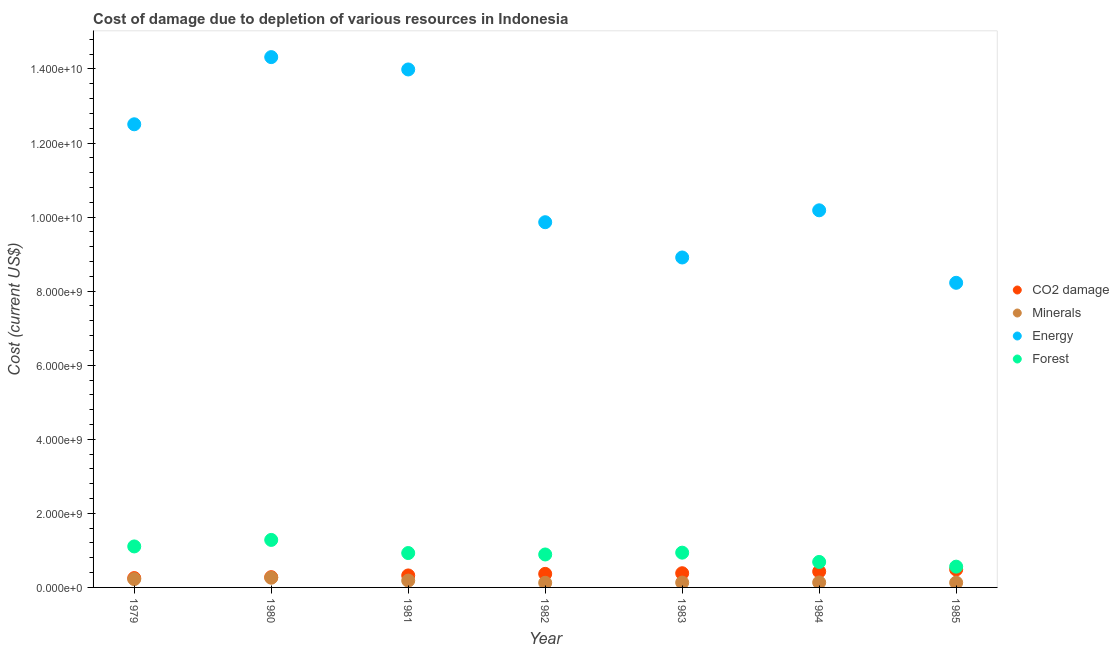How many different coloured dotlines are there?
Keep it short and to the point. 4. Is the number of dotlines equal to the number of legend labels?
Offer a terse response. Yes. What is the cost of damage due to depletion of minerals in 1984?
Provide a short and direct response. 1.34e+08. Across all years, what is the maximum cost of damage due to depletion of coal?
Your response must be concise. 4.84e+08. Across all years, what is the minimum cost of damage due to depletion of energy?
Keep it short and to the point. 8.23e+09. In which year was the cost of damage due to depletion of coal minimum?
Provide a short and direct response. 1979. What is the total cost of damage due to depletion of minerals in the graph?
Give a very brief answer. 1.19e+09. What is the difference between the cost of damage due to depletion of coal in 1979 and that in 1980?
Offer a very short reply. -2.50e+07. What is the difference between the cost of damage due to depletion of coal in 1983 and the cost of damage due to depletion of forests in 1980?
Provide a short and direct response. -9.00e+08. What is the average cost of damage due to depletion of energy per year?
Your answer should be very brief. 1.11e+1. In the year 1984, what is the difference between the cost of damage due to depletion of forests and cost of damage due to depletion of energy?
Ensure brevity in your answer.  -9.50e+09. What is the ratio of the cost of damage due to depletion of energy in 1980 to that in 1983?
Your answer should be compact. 1.61. Is the cost of damage due to depletion of coal in 1983 less than that in 1984?
Offer a very short reply. Yes. What is the difference between the highest and the second highest cost of damage due to depletion of coal?
Your response must be concise. 5.51e+07. What is the difference between the highest and the lowest cost of damage due to depletion of minerals?
Provide a short and direct response. 1.37e+08. Is it the case that in every year, the sum of the cost of damage due to depletion of energy and cost of damage due to depletion of minerals is greater than the sum of cost of damage due to depletion of coal and cost of damage due to depletion of forests?
Give a very brief answer. Yes. Is it the case that in every year, the sum of the cost of damage due to depletion of coal and cost of damage due to depletion of minerals is greater than the cost of damage due to depletion of energy?
Your answer should be very brief. No. Does the cost of damage due to depletion of minerals monotonically increase over the years?
Make the answer very short. No. Is the cost of damage due to depletion of energy strictly greater than the cost of damage due to depletion of forests over the years?
Ensure brevity in your answer.  Yes. Is the cost of damage due to depletion of energy strictly less than the cost of damage due to depletion of coal over the years?
Make the answer very short. No. Are the values on the major ticks of Y-axis written in scientific E-notation?
Your answer should be compact. Yes. Does the graph contain any zero values?
Your answer should be very brief. No. Where does the legend appear in the graph?
Your answer should be very brief. Center right. How are the legend labels stacked?
Ensure brevity in your answer.  Vertical. What is the title of the graph?
Make the answer very short. Cost of damage due to depletion of various resources in Indonesia . Does "Rule based governance" appear as one of the legend labels in the graph?
Keep it short and to the point. No. What is the label or title of the X-axis?
Keep it short and to the point. Year. What is the label or title of the Y-axis?
Ensure brevity in your answer.  Cost (current US$). What is the Cost (current US$) of CO2 damage in 1979?
Your response must be concise. 2.52e+08. What is the Cost (current US$) in Minerals in 1979?
Provide a succinct answer. 2.25e+08. What is the Cost (current US$) in Energy in 1979?
Provide a short and direct response. 1.25e+1. What is the Cost (current US$) of Forest in 1979?
Provide a short and direct response. 1.11e+09. What is the Cost (current US$) of CO2 damage in 1980?
Your answer should be very brief. 2.77e+08. What is the Cost (current US$) of Minerals in 1980?
Make the answer very short. 2.62e+08. What is the Cost (current US$) in Energy in 1980?
Keep it short and to the point. 1.43e+1. What is the Cost (current US$) of Forest in 1980?
Offer a terse response. 1.28e+09. What is the Cost (current US$) in CO2 damage in 1981?
Keep it short and to the point. 3.24e+08. What is the Cost (current US$) in Minerals in 1981?
Offer a very short reply. 1.85e+08. What is the Cost (current US$) of Energy in 1981?
Provide a short and direct response. 1.40e+1. What is the Cost (current US$) of Forest in 1981?
Keep it short and to the point. 9.29e+08. What is the Cost (current US$) in CO2 damage in 1982?
Your response must be concise. 3.66e+08. What is the Cost (current US$) of Minerals in 1982?
Ensure brevity in your answer.  1.25e+08. What is the Cost (current US$) in Energy in 1982?
Offer a terse response. 9.86e+09. What is the Cost (current US$) in Forest in 1982?
Offer a very short reply. 8.90e+08. What is the Cost (current US$) of CO2 damage in 1983?
Your answer should be compact. 3.83e+08. What is the Cost (current US$) of Minerals in 1983?
Ensure brevity in your answer.  1.31e+08. What is the Cost (current US$) of Energy in 1983?
Offer a terse response. 8.91e+09. What is the Cost (current US$) of Forest in 1983?
Ensure brevity in your answer.  9.39e+08. What is the Cost (current US$) of CO2 damage in 1984?
Give a very brief answer. 4.29e+08. What is the Cost (current US$) in Minerals in 1984?
Offer a very short reply. 1.34e+08. What is the Cost (current US$) in Energy in 1984?
Provide a short and direct response. 1.02e+1. What is the Cost (current US$) of Forest in 1984?
Your answer should be very brief. 6.88e+08. What is the Cost (current US$) in CO2 damage in 1985?
Offer a very short reply. 4.84e+08. What is the Cost (current US$) in Minerals in 1985?
Offer a very short reply. 1.29e+08. What is the Cost (current US$) in Energy in 1985?
Your answer should be compact. 8.23e+09. What is the Cost (current US$) in Forest in 1985?
Make the answer very short. 5.61e+08. Across all years, what is the maximum Cost (current US$) of CO2 damage?
Give a very brief answer. 4.84e+08. Across all years, what is the maximum Cost (current US$) in Minerals?
Ensure brevity in your answer.  2.62e+08. Across all years, what is the maximum Cost (current US$) of Energy?
Make the answer very short. 1.43e+1. Across all years, what is the maximum Cost (current US$) of Forest?
Offer a terse response. 1.28e+09. Across all years, what is the minimum Cost (current US$) of CO2 damage?
Provide a succinct answer. 2.52e+08. Across all years, what is the minimum Cost (current US$) in Minerals?
Your answer should be compact. 1.25e+08. Across all years, what is the minimum Cost (current US$) of Energy?
Offer a very short reply. 8.23e+09. Across all years, what is the minimum Cost (current US$) in Forest?
Give a very brief answer. 5.61e+08. What is the total Cost (current US$) in CO2 damage in the graph?
Keep it short and to the point. 2.52e+09. What is the total Cost (current US$) in Minerals in the graph?
Your answer should be very brief. 1.19e+09. What is the total Cost (current US$) in Energy in the graph?
Your answer should be compact. 7.80e+1. What is the total Cost (current US$) in Forest in the graph?
Your answer should be compact. 6.40e+09. What is the difference between the Cost (current US$) of CO2 damage in 1979 and that in 1980?
Give a very brief answer. -2.50e+07. What is the difference between the Cost (current US$) of Minerals in 1979 and that in 1980?
Your answer should be compact. -3.74e+07. What is the difference between the Cost (current US$) of Energy in 1979 and that in 1980?
Your answer should be compact. -1.81e+09. What is the difference between the Cost (current US$) in Forest in 1979 and that in 1980?
Provide a succinct answer. -1.76e+08. What is the difference between the Cost (current US$) in CO2 damage in 1979 and that in 1981?
Keep it short and to the point. -7.18e+07. What is the difference between the Cost (current US$) of Minerals in 1979 and that in 1981?
Your response must be concise. 4.05e+07. What is the difference between the Cost (current US$) of Energy in 1979 and that in 1981?
Make the answer very short. -1.48e+09. What is the difference between the Cost (current US$) of Forest in 1979 and that in 1981?
Keep it short and to the point. 1.78e+08. What is the difference between the Cost (current US$) in CO2 damage in 1979 and that in 1982?
Give a very brief answer. -1.14e+08. What is the difference between the Cost (current US$) of Minerals in 1979 and that in 1982?
Make the answer very short. 1.00e+08. What is the difference between the Cost (current US$) in Energy in 1979 and that in 1982?
Offer a terse response. 2.64e+09. What is the difference between the Cost (current US$) of Forest in 1979 and that in 1982?
Provide a succinct answer. 2.17e+08. What is the difference between the Cost (current US$) in CO2 damage in 1979 and that in 1983?
Your answer should be compact. -1.31e+08. What is the difference between the Cost (current US$) of Minerals in 1979 and that in 1983?
Provide a short and direct response. 9.44e+07. What is the difference between the Cost (current US$) of Energy in 1979 and that in 1983?
Your answer should be compact. 3.60e+09. What is the difference between the Cost (current US$) of Forest in 1979 and that in 1983?
Ensure brevity in your answer.  1.68e+08. What is the difference between the Cost (current US$) of CO2 damage in 1979 and that in 1984?
Provide a succinct answer. -1.77e+08. What is the difference between the Cost (current US$) of Minerals in 1979 and that in 1984?
Offer a terse response. 9.06e+07. What is the difference between the Cost (current US$) in Energy in 1979 and that in 1984?
Keep it short and to the point. 2.32e+09. What is the difference between the Cost (current US$) in Forest in 1979 and that in 1984?
Offer a terse response. 4.19e+08. What is the difference between the Cost (current US$) of CO2 damage in 1979 and that in 1985?
Provide a succinct answer. -2.33e+08. What is the difference between the Cost (current US$) of Minerals in 1979 and that in 1985?
Make the answer very short. 9.65e+07. What is the difference between the Cost (current US$) in Energy in 1979 and that in 1985?
Offer a terse response. 4.28e+09. What is the difference between the Cost (current US$) in Forest in 1979 and that in 1985?
Offer a terse response. 5.46e+08. What is the difference between the Cost (current US$) of CO2 damage in 1980 and that in 1981?
Your answer should be compact. -4.68e+07. What is the difference between the Cost (current US$) of Minerals in 1980 and that in 1981?
Ensure brevity in your answer.  7.79e+07. What is the difference between the Cost (current US$) in Energy in 1980 and that in 1981?
Give a very brief answer. 3.34e+08. What is the difference between the Cost (current US$) of Forest in 1980 and that in 1981?
Your answer should be compact. 3.54e+08. What is the difference between the Cost (current US$) of CO2 damage in 1980 and that in 1982?
Keep it short and to the point. -8.91e+07. What is the difference between the Cost (current US$) in Minerals in 1980 and that in 1982?
Offer a terse response. 1.37e+08. What is the difference between the Cost (current US$) in Energy in 1980 and that in 1982?
Provide a short and direct response. 4.46e+09. What is the difference between the Cost (current US$) in Forest in 1980 and that in 1982?
Your answer should be compact. 3.93e+08. What is the difference between the Cost (current US$) in CO2 damage in 1980 and that in 1983?
Your answer should be compact. -1.06e+08. What is the difference between the Cost (current US$) of Minerals in 1980 and that in 1983?
Keep it short and to the point. 1.32e+08. What is the difference between the Cost (current US$) in Energy in 1980 and that in 1983?
Give a very brief answer. 5.41e+09. What is the difference between the Cost (current US$) of Forest in 1980 and that in 1983?
Provide a short and direct response. 3.44e+08. What is the difference between the Cost (current US$) of CO2 damage in 1980 and that in 1984?
Offer a terse response. -1.52e+08. What is the difference between the Cost (current US$) of Minerals in 1980 and that in 1984?
Offer a terse response. 1.28e+08. What is the difference between the Cost (current US$) of Energy in 1980 and that in 1984?
Give a very brief answer. 4.14e+09. What is the difference between the Cost (current US$) in Forest in 1980 and that in 1984?
Ensure brevity in your answer.  5.95e+08. What is the difference between the Cost (current US$) of CO2 damage in 1980 and that in 1985?
Provide a succinct answer. -2.07e+08. What is the difference between the Cost (current US$) of Minerals in 1980 and that in 1985?
Provide a succinct answer. 1.34e+08. What is the difference between the Cost (current US$) of Energy in 1980 and that in 1985?
Your answer should be very brief. 6.09e+09. What is the difference between the Cost (current US$) of Forest in 1980 and that in 1985?
Offer a very short reply. 7.22e+08. What is the difference between the Cost (current US$) in CO2 damage in 1981 and that in 1982?
Provide a short and direct response. -4.23e+07. What is the difference between the Cost (current US$) of Minerals in 1981 and that in 1982?
Your response must be concise. 5.96e+07. What is the difference between the Cost (current US$) in Energy in 1981 and that in 1982?
Your answer should be very brief. 4.12e+09. What is the difference between the Cost (current US$) of Forest in 1981 and that in 1982?
Your answer should be compact. 3.88e+07. What is the difference between the Cost (current US$) of CO2 damage in 1981 and that in 1983?
Offer a very short reply. -5.96e+07. What is the difference between the Cost (current US$) of Minerals in 1981 and that in 1983?
Your answer should be very brief. 5.39e+07. What is the difference between the Cost (current US$) of Energy in 1981 and that in 1983?
Give a very brief answer. 5.08e+09. What is the difference between the Cost (current US$) in Forest in 1981 and that in 1983?
Make the answer very short. -1.02e+07. What is the difference between the Cost (current US$) of CO2 damage in 1981 and that in 1984?
Your answer should be compact. -1.06e+08. What is the difference between the Cost (current US$) in Minerals in 1981 and that in 1984?
Provide a short and direct response. 5.01e+07. What is the difference between the Cost (current US$) in Energy in 1981 and that in 1984?
Provide a short and direct response. 3.80e+09. What is the difference between the Cost (current US$) in Forest in 1981 and that in 1984?
Your answer should be very brief. 2.40e+08. What is the difference between the Cost (current US$) of CO2 damage in 1981 and that in 1985?
Keep it short and to the point. -1.61e+08. What is the difference between the Cost (current US$) of Minerals in 1981 and that in 1985?
Make the answer very short. 5.59e+07. What is the difference between the Cost (current US$) of Energy in 1981 and that in 1985?
Keep it short and to the point. 5.76e+09. What is the difference between the Cost (current US$) in Forest in 1981 and that in 1985?
Offer a terse response. 3.68e+08. What is the difference between the Cost (current US$) in CO2 damage in 1982 and that in 1983?
Offer a terse response. -1.73e+07. What is the difference between the Cost (current US$) of Minerals in 1982 and that in 1983?
Your response must be concise. -5.73e+06. What is the difference between the Cost (current US$) in Energy in 1982 and that in 1983?
Provide a short and direct response. 9.53e+08. What is the difference between the Cost (current US$) of Forest in 1982 and that in 1983?
Offer a terse response. -4.90e+07. What is the difference between the Cost (current US$) in CO2 damage in 1982 and that in 1984?
Your answer should be very brief. -6.32e+07. What is the difference between the Cost (current US$) in Minerals in 1982 and that in 1984?
Your response must be concise. -9.49e+06. What is the difference between the Cost (current US$) in Energy in 1982 and that in 1984?
Keep it short and to the point. -3.21e+08. What is the difference between the Cost (current US$) in Forest in 1982 and that in 1984?
Keep it short and to the point. 2.01e+08. What is the difference between the Cost (current US$) in CO2 damage in 1982 and that in 1985?
Offer a terse response. -1.18e+08. What is the difference between the Cost (current US$) of Minerals in 1982 and that in 1985?
Your answer should be compact. -3.65e+06. What is the difference between the Cost (current US$) of Energy in 1982 and that in 1985?
Offer a very short reply. 1.64e+09. What is the difference between the Cost (current US$) of Forest in 1982 and that in 1985?
Your answer should be very brief. 3.29e+08. What is the difference between the Cost (current US$) in CO2 damage in 1983 and that in 1984?
Your answer should be very brief. -4.59e+07. What is the difference between the Cost (current US$) of Minerals in 1983 and that in 1984?
Make the answer very short. -3.76e+06. What is the difference between the Cost (current US$) in Energy in 1983 and that in 1984?
Your response must be concise. -1.27e+09. What is the difference between the Cost (current US$) in Forest in 1983 and that in 1984?
Ensure brevity in your answer.  2.51e+08. What is the difference between the Cost (current US$) in CO2 damage in 1983 and that in 1985?
Your response must be concise. -1.01e+08. What is the difference between the Cost (current US$) in Minerals in 1983 and that in 1985?
Your response must be concise. 2.08e+06. What is the difference between the Cost (current US$) of Energy in 1983 and that in 1985?
Ensure brevity in your answer.  6.84e+08. What is the difference between the Cost (current US$) of Forest in 1983 and that in 1985?
Your answer should be very brief. 3.78e+08. What is the difference between the Cost (current US$) in CO2 damage in 1984 and that in 1985?
Give a very brief answer. -5.51e+07. What is the difference between the Cost (current US$) in Minerals in 1984 and that in 1985?
Give a very brief answer. 5.84e+06. What is the difference between the Cost (current US$) of Energy in 1984 and that in 1985?
Keep it short and to the point. 1.96e+09. What is the difference between the Cost (current US$) of Forest in 1984 and that in 1985?
Make the answer very short. 1.27e+08. What is the difference between the Cost (current US$) of CO2 damage in 1979 and the Cost (current US$) of Minerals in 1980?
Your answer should be compact. -1.05e+07. What is the difference between the Cost (current US$) of CO2 damage in 1979 and the Cost (current US$) of Energy in 1980?
Keep it short and to the point. -1.41e+1. What is the difference between the Cost (current US$) in CO2 damage in 1979 and the Cost (current US$) in Forest in 1980?
Keep it short and to the point. -1.03e+09. What is the difference between the Cost (current US$) in Minerals in 1979 and the Cost (current US$) in Energy in 1980?
Keep it short and to the point. -1.41e+1. What is the difference between the Cost (current US$) of Minerals in 1979 and the Cost (current US$) of Forest in 1980?
Keep it short and to the point. -1.06e+09. What is the difference between the Cost (current US$) of Energy in 1979 and the Cost (current US$) of Forest in 1980?
Your answer should be very brief. 1.12e+1. What is the difference between the Cost (current US$) in CO2 damage in 1979 and the Cost (current US$) in Minerals in 1981?
Keep it short and to the point. 6.74e+07. What is the difference between the Cost (current US$) in CO2 damage in 1979 and the Cost (current US$) in Energy in 1981?
Your response must be concise. -1.37e+1. What is the difference between the Cost (current US$) in CO2 damage in 1979 and the Cost (current US$) in Forest in 1981?
Offer a terse response. -6.77e+08. What is the difference between the Cost (current US$) of Minerals in 1979 and the Cost (current US$) of Energy in 1981?
Offer a terse response. -1.38e+1. What is the difference between the Cost (current US$) of Minerals in 1979 and the Cost (current US$) of Forest in 1981?
Your answer should be very brief. -7.03e+08. What is the difference between the Cost (current US$) in Energy in 1979 and the Cost (current US$) in Forest in 1981?
Ensure brevity in your answer.  1.16e+1. What is the difference between the Cost (current US$) of CO2 damage in 1979 and the Cost (current US$) of Minerals in 1982?
Your response must be concise. 1.27e+08. What is the difference between the Cost (current US$) in CO2 damage in 1979 and the Cost (current US$) in Energy in 1982?
Offer a very short reply. -9.61e+09. What is the difference between the Cost (current US$) in CO2 damage in 1979 and the Cost (current US$) in Forest in 1982?
Provide a succinct answer. -6.38e+08. What is the difference between the Cost (current US$) in Minerals in 1979 and the Cost (current US$) in Energy in 1982?
Provide a short and direct response. -9.64e+09. What is the difference between the Cost (current US$) of Minerals in 1979 and the Cost (current US$) of Forest in 1982?
Offer a terse response. -6.65e+08. What is the difference between the Cost (current US$) of Energy in 1979 and the Cost (current US$) of Forest in 1982?
Your answer should be very brief. 1.16e+1. What is the difference between the Cost (current US$) in CO2 damage in 1979 and the Cost (current US$) in Minerals in 1983?
Provide a short and direct response. 1.21e+08. What is the difference between the Cost (current US$) in CO2 damage in 1979 and the Cost (current US$) in Energy in 1983?
Offer a terse response. -8.66e+09. What is the difference between the Cost (current US$) in CO2 damage in 1979 and the Cost (current US$) in Forest in 1983?
Provide a succinct answer. -6.87e+08. What is the difference between the Cost (current US$) in Minerals in 1979 and the Cost (current US$) in Energy in 1983?
Your answer should be very brief. -8.68e+09. What is the difference between the Cost (current US$) in Minerals in 1979 and the Cost (current US$) in Forest in 1983?
Your response must be concise. -7.14e+08. What is the difference between the Cost (current US$) of Energy in 1979 and the Cost (current US$) of Forest in 1983?
Offer a very short reply. 1.16e+1. What is the difference between the Cost (current US$) of CO2 damage in 1979 and the Cost (current US$) of Minerals in 1984?
Offer a very short reply. 1.17e+08. What is the difference between the Cost (current US$) in CO2 damage in 1979 and the Cost (current US$) in Energy in 1984?
Ensure brevity in your answer.  -9.93e+09. What is the difference between the Cost (current US$) of CO2 damage in 1979 and the Cost (current US$) of Forest in 1984?
Your response must be concise. -4.36e+08. What is the difference between the Cost (current US$) of Minerals in 1979 and the Cost (current US$) of Energy in 1984?
Your answer should be very brief. -9.96e+09. What is the difference between the Cost (current US$) in Minerals in 1979 and the Cost (current US$) in Forest in 1984?
Give a very brief answer. -4.63e+08. What is the difference between the Cost (current US$) in Energy in 1979 and the Cost (current US$) in Forest in 1984?
Give a very brief answer. 1.18e+1. What is the difference between the Cost (current US$) of CO2 damage in 1979 and the Cost (current US$) of Minerals in 1985?
Offer a very short reply. 1.23e+08. What is the difference between the Cost (current US$) of CO2 damage in 1979 and the Cost (current US$) of Energy in 1985?
Make the answer very short. -7.97e+09. What is the difference between the Cost (current US$) of CO2 damage in 1979 and the Cost (current US$) of Forest in 1985?
Offer a very short reply. -3.09e+08. What is the difference between the Cost (current US$) of Minerals in 1979 and the Cost (current US$) of Energy in 1985?
Your answer should be compact. -8.00e+09. What is the difference between the Cost (current US$) of Minerals in 1979 and the Cost (current US$) of Forest in 1985?
Offer a very short reply. -3.36e+08. What is the difference between the Cost (current US$) of Energy in 1979 and the Cost (current US$) of Forest in 1985?
Offer a terse response. 1.19e+1. What is the difference between the Cost (current US$) of CO2 damage in 1980 and the Cost (current US$) of Minerals in 1981?
Make the answer very short. 9.24e+07. What is the difference between the Cost (current US$) in CO2 damage in 1980 and the Cost (current US$) in Energy in 1981?
Provide a short and direct response. -1.37e+1. What is the difference between the Cost (current US$) of CO2 damage in 1980 and the Cost (current US$) of Forest in 1981?
Your response must be concise. -6.52e+08. What is the difference between the Cost (current US$) in Minerals in 1980 and the Cost (current US$) in Energy in 1981?
Your answer should be very brief. -1.37e+1. What is the difference between the Cost (current US$) of Minerals in 1980 and the Cost (current US$) of Forest in 1981?
Your answer should be very brief. -6.66e+08. What is the difference between the Cost (current US$) in Energy in 1980 and the Cost (current US$) in Forest in 1981?
Ensure brevity in your answer.  1.34e+1. What is the difference between the Cost (current US$) in CO2 damage in 1980 and the Cost (current US$) in Minerals in 1982?
Provide a short and direct response. 1.52e+08. What is the difference between the Cost (current US$) in CO2 damage in 1980 and the Cost (current US$) in Energy in 1982?
Give a very brief answer. -9.59e+09. What is the difference between the Cost (current US$) in CO2 damage in 1980 and the Cost (current US$) in Forest in 1982?
Make the answer very short. -6.13e+08. What is the difference between the Cost (current US$) of Minerals in 1980 and the Cost (current US$) of Energy in 1982?
Make the answer very short. -9.60e+09. What is the difference between the Cost (current US$) in Minerals in 1980 and the Cost (current US$) in Forest in 1982?
Keep it short and to the point. -6.27e+08. What is the difference between the Cost (current US$) in Energy in 1980 and the Cost (current US$) in Forest in 1982?
Provide a short and direct response. 1.34e+1. What is the difference between the Cost (current US$) of CO2 damage in 1980 and the Cost (current US$) of Minerals in 1983?
Make the answer very short. 1.46e+08. What is the difference between the Cost (current US$) in CO2 damage in 1980 and the Cost (current US$) in Energy in 1983?
Keep it short and to the point. -8.63e+09. What is the difference between the Cost (current US$) of CO2 damage in 1980 and the Cost (current US$) of Forest in 1983?
Your answer should be compact. -6.62e+08. What is the difference between the Cost (current US$) in Minerals in 1980 and the Cost (current US$) in Energy in 1983?
Your answer should be very brief. -8.65e+09. What is the difference between the Cost (current US$) of Minerals in 1980 and the Cost (current US$) of Forest in 1983?
Offer a very short reply. -6.76e+08. What is the difference between the Cost (current US$) in Energy in 1980 and the Cost (current US$) in Forest in 1983?
Provide a succinct answer. 1.34e+1. What is the difference between the Cost (current US$) of CO2 damage in 1980 and the Cost (current US$) of Minerals in 1984?
Your answer should be very brief. 1.42e+08. What is the difference between the Cost (current US$) of CO2 damage in 1980 and the Cost (current US$) of Energy in 1984?
Provide a succinct answer. -9.91e+09. What is the difference between the Cost (current US$) in CO2 damage in 1980 and the Cost (current US$) in Forest in 1984?
Provide a succinct answer. -4.11e+08. What is the difference between the Cost (current US$) of Minerals in 1980 and the Cost (current US$) of Energy in 1984?
Offer a terse response. -9.92e+09. What is the difference between the Cost (current US$) in Minerals in 1980 and the Cost (current US$) in Forest in 1984?
Provide a short and direct response. -4.26e+08. What is the difference between the Cost (current US$) of Energy in 1980 and the Cost (current US$) of Forest in 1984?
Your answer should be compact. 1.36e+1. What is the difference between the Cost (current US$) in CO2 damage in 1980 and the Cost (current US$) in Minerals in 1985?
Offer a terse response. 1.48e+08. What is the difference between the Cost (current US$) of CO2 damage in 1980 and the Cost (current US$) of Energy in 1985?
Your response must be concise. -7.95e+09. What is the difference between the Cost (current US$) of CO2 damage in 1980 and the Cost (current US$) of Forest in 1985?
Your answer should be very brief. -2.84e+08. What is the difference between the Cost (current US$) of Minerals in 1980 and the Cost (current US$) of Energy in 1985?
Provide a short and direct response. -7.96e+09. What is the difference between the Cost (current US$) in Minerals in 1980 and the Cost (current US$) in Forest in 1985?
Provide a short and direct response. -2.99e+08. What is the difference between the Cost (current US$) of Energy in 1980 and the Cost (current US$) of Forest in 1985?
Your answer should be compact. 1.38e+1. What is the difference between the Cost (current US$) of CO2 damage in 1981 and the Cost (current US$) of Minerals in 1982?
Ensure brevity in your answer.  1.99e+08. What is the difference between the Cost (current US$) in CO2 damage in 1981 and the Cost (current US$) in Energy in 1982?
Make the answer very short. -9.54e+09. What is the difference between the Cost (current US$) in CO2 damage in 1981 and the Cost (current US$) in Forest in 1982?
Provide a succinct answer. -5.66e+08. What is the difference between the Cost (current US$) in Minerals in 1981 and the Cost (current US$) in Energy in 1982?
Give a very brief answer. -9.68e+09. What is the difference between the Cost (current US$) in Minerals in 1981 and the Cost (current US$) in Forest in 1982?
Your answer should be compact. -7.05e+08. What is the difference between the Cost (current US$) in Energy in 1981 and the Cost (current US$) in Forest in 1982?
Your answer should be compact. 1.31e+1. What is the difference between the Cost (current US$) of CO2 damage in 1981 and the Cost (current US$) of Minerals in 1983?
Offer a very short reply. 1.93e+08. What is the difference between the Cost (current US$) in CO2 damage in 1981 and the Cost (current US$) in Energy in 1983?
Provide a succinct answer. -8.59e+09. What is the difference between the Cost (current US$) of CO2 damage in 1981 and the Cost (current US$) of Forest in 1983?
Your answer should be very brief. -6.15e+08. What is the difference between the Cost (current US$) of Minerals in 1981 and the Cost (current US$) of Energy in 1983?
Give a very brief answer. -8.73e+09. What is the difference between the Cost (current US$) in Minerals in 1981 and the Cost (current US$) in Forest in 1983?
Your answer should be compact. -7.54e+08. What is the difference between the Cost (current US$) of Energy in 1981 and the Cost (current US$) of Forest in 1983?
Your answer should be very brief. 1.30e+1. What is the difference between the Cost (current US$) of CO2 damage in 1981 and the Cost (current US$) of Minerals in 1984?
Offer a very short reply. 1.89e+08. What is the difference between the Cost (current US$) of CO2 damage in 1981 and the Cost (current US$) of Energy in 1984?
Offer a terse response. -9.86e+09. What is the difference between the Cost (current US$) in CO2 damage in 1981 and the Cost (current US$) in Forest in 1984?
Offer a terse response. -3.65e+08. What is the difference between the Cost (current US$) of Minerals in 1981 and the Cost (current US$) of Energy in 1984?
Your answer should be very brief. -1.00e+1. What is the difference between the Cost (current US$) of Minerals in 1981 and the Cost (current US$) of Forest in 1984?
Your answer should be very brief. -5.04e+08. What is the difference between the Cost (current US$) in Energy in 1981 and the Cost (current US$) in Forest in 1984?
Provide a short and direct response. 1.33e+1. What is the difference between the Cost (current US$) in CO2 damage in 1981 and the Cost (current US$) in Minerals in 1985?
Your answer should be compact. 1.95e+08. What is the difference between the Cost (current US$) of CO2 damage in 1981 and the Cost (current US$) of Energy in 1985?
Offer a very short reply. -7.90e+09. What is the difference between the Cost (current US$) in CO2 damage in 1981 and the Cost (current US$) in Forest in 1985?
Keep it short and to the point. -2.37e+08. What is the difference between the Cost (current US$) in Minerals in 1981 and the Cost (current US$) in Energy in 1985?
Your response must be concise. -8.04e+09. What is the difference between the Cost (current US$) of Minerals in 1981 and the Cost (current US$) of Forest in 1985?
Your response must be concise. -3.76e+08. What is the difference between the Cost (current US$) of Energy in 1981 and the Cost (current US$) of Forest in 1985?
Your response must be concise. 1.34e+1. What is the difference between the Cost (current US$) of CO2 damage in 1982 and the Cost (current US$) of Minerals in 1983?
Make the answer very short. 2.35e+08. What is the difference between the Cost (current US$) in CO2 damage in 1982 and the Cost (current US$) in Energy in 1983?
Keep it short and to the point. -8.54e+09. What is the difference between the Cost (current US$) in CO2 damage in 1982 and the Cost (current US$) in Forest in 1983?
Keep it short and to the point. -5.73e+08. What is the difference between the Cost (current US$) in Minerals in 1982 and the Cost (current US$) in Energy in 1983?
Provide a short and direct response. -8.79e+09. What is the difference between the Cost (current US$) of Minerals in 1982 and the Cost (current US$) of Forest in 1983?
Keep it short and to the point. -8.14e+08. What is the difference between the Cost (current US$) in Energy in 1982 and the Cost (current US$) in Forest in 1983?
Give a very brief answer. 8.92e+09. What is the difference between the Cost (current US$) in CO2 damage in 1982 and the Cost (current US$) in Minerals in 1984?
Give a very brief answer. 2.32e+08. What is the difference between the Cost (current US$) of CO2 damage in 1982 and the Cost (current US$) of Energy in 1984?
Your answer should be very brief. -9.82e+09. What is the difference between the Cost (current US$) of CO2 damage in 1982 and the Cost (current US$) of Forest in 1984?
Give a very brief answer. -3.22e+08. What is the difference between the Cost (current US$) in Minerals in 1982 and the Cost (current US$) in Energy in 1984?
Your response must be concise. -1.01e+1. What is the difference between the Cost (current US$) of Minerals in 1982 and the Cost (current US$) of Forest in 1984?
Offer a terse response. -5.63e+08. What is the difference between the Cost (current US$) in Energy in 1982 and the Cost (current US$) in Forest in 1984?
Your answer should be very brief. 9.17e+09. What is the difference between the Cost (current US$) of CO2 damage in 1982 and the Cost (current US$) of Minerals in 1985?
Offer a very short reply. 2.37e+08. What is the difference between the Cost (current US$) in CO2 damage in 1982 and the Cost (current US$) in Energy in 1985?
Offer a terse response. -7.86e+09. What is the difference between the Cost (current US$) of CO2 damage in 1982 and the Cost (current US$) of Forest in 1985?
Your response must be concise. -1.95e+08. What is the difference between the Cost (current US$) of Minerals in 1982 and the Cost (current US$) of Energy in 1985?
Ensure brevity in your answer.  -8.10e+09. What is the difference between the Cost (current US$) of Minerals in 1982 and the Cost (current US$) of Forest in 1985?
Ensure brevity in your answer.  -4.36e+08. What is the difference between the Cost (current US$) in Energy in 1982 and the Cost (current US$) in Forest in 1985?
Ensure brevity in your answer.  9.30e+09. What is the difference between the Cost (current US$) in CO2 damage in 1983 and the Cost (current US$) in Minerals in 1984?
Make the answer very short. 2.49e+08. What is the difference between the Cost (current US$) of CO2 damage in 1983 and the Cost (current US$) of Energy in 1984?
Ensure brevity in your answer.  -9.80e+09. What is the difference between the Cost (current US$) of CO2 damage in 1983 and the Cost (current US$) of Forest in 1984?
Keep it short and to the point. -3.05e+08. What is the difference between the Cost (current US$) in Minerals in 1983 and the Cost (current US$) in Energy in 1984?
Keep it short and to the point. -1.01e+1. What is the difference between the Cost (current US$) in Minerals in 1983 and the Cost (current US$) in Forest in 1984?
Provide a succinct answer. -5.58e+08. What is the difference between the Cost (current US$) of Energy in 1983 and the Cost (current US$) of Forest in 1984?
Ensure brevity in your answer.  8.22e+09. What is the difference between the Cost (current US$) in CO2 damage in 1983 and the Cost (current US$) in Minerals in 1985?
Offer a terse response. 2.55e+08. What is the difference between the Cost (current US$) of CO2 damage in 1983 and the Cost (current US$) of Energy in 1985?
Ensure brevity in your answer.  -7.84e+09. What is the difference between the Cost (current US$) in CO2 damage in 1983 and the Cost (current US$) in Forest in 1985?
Give a very brief answer. -1.78e+08. What is the difference between the Cost (current US$) of Minerals in 1983 and the Cost (current US$) of Energy in 1985?
Offer a very short reply. -8.10e+09. What is the difference between the Cost (current US$) in Minerals in 1983 and the Cost (current US$) in Forest in 1985?
Make the answer very short. -4.30e+08. What is the difference between the Cost (current US$) in Energy in 1983 and the Cost (current US$) in Forest in 1985?
Your response must be concise. 8.35e+09. What is the difference between the Cost (current US$) of CO2 damage in 1984 and the Cost (current US$) of Minerals in 1985?
Offer a terse response. 3.01e+08. What is the difference between the Cost (current US$) of CO2 damage in 1984 and the Cost (current US$) of Energy in 1985?
Ensure brevity in your answer.  -7.80e+09. What is the difference between the Cost (current US$) of CO2 damage in 1984 and the Cost (current US$) of Forest in 1985?
Keep it short and to the point. -1.32e+08. What is the difference between the Cost (current US$) of Minerals in 1984 and the Cost (current US$) of Energy in 1985?
Your answer should be compact. -8.09e+09. What is the difference between the Cost (current US$) in Minerals in 1984 and the Cost (current US$) in Forest in 1985?
Offer a terse response. -4.26e+08. What is the difference between the Cost (current US$) of Energy in 1984 and the Cost (current US$) of Forest in 1985?
Give a very brief answer. 9.62e+09. What is the average Cost (current US$) of CO2 damage per year?
Offer a terse response. 3.59e+08. What is the average Cost (current US$) in Minerals per year?
Offer a terse response. 1.70e+08. What is the average Cost (current US$) in Energy per year?
Provide a short and direct response. 1.11e+1. What is the average Cost (current US$) of Forest per year?
Provide a succinct answer. 9.14e+08. In the year 1979, what is the difference between the Cost (current US$) of CO2 damage and Cost (current US$) of Minerals?
Your answer should be very brief. 2.68e+07. In the year 1979, what is the difference between the Cost (current US$) of CO2 damage and Cost (current US$) of Energy?
Provide a short and direct response. -1.23e+1. In the year 1979, what is the difference between the Cost (current US$) of CO2 damage and Cost (current US$) of Forest?
Your response must be concise. -8.55e+08. In the year 1979, what is the difference between the Cost (current US$) of Minerals and Cost (current US$) of Energy?
Give a very brief answer. -1.23e+1. In the year 1979, what is the difference between the Cost (current US$) of Minerals and Cost (current US$) of Forest?
Offer a terse response. -8.82e+08. In the year 1979, what is the difference between the Cost (current US$) in Energy and Cost (current US$) in Forest?
Ensure brevity in your answer.  1.14e+1. In the year 1980, what is the difference between the Cost (current US$) in CO2 damage and Cost (current US$) in Minerals?
Your answer should be compact. 1.45e+07. In the year 1980, what is the difference between the Cost (current US$) in CO2 damage and Cost (current US$) in Energy?
Make the answer very short. -1.40e+1. In the year 1980, what is the difference between the Cost (current US$) of CO2 damage and Cost (current US$) of Forest?
Your answer should be very brief. -1.01e+09. In the year 1980, what is the difference between the Cost (current US$) in Minerals and Cost (current US$) in Energy?
Ensure brevity in your answer.  -1.41e+1. In the year 1980, what is the difference between the Cost (current US$) in Minerals and Cost (current US$) in Forest?
Offer a terse response. -1.02e+09. In the year 1980, what is the difference between the Cost (current US$) in Energy and Cost (current US$) in Forest?
Provide a succinct answer. 1.30e+1. In the year 1981, what is the difference between the Cost (current US$) of CO2 damage and Cost (current US$) of Minerals?
Your response must be concise. 1.39e+08. In the year 1981, what is the difference between the Cost (current US$) of CO2 damage and Cost (current US$) of Energy?
Provide a succinct answer. -1.37e+1. In the year 1981, what is the difference between the Cost (current US$) of CO2 damage and Cost (current US$) of Forest?
Provide a succinct answer. -6.05e+08. In the year 1981, what is the difference between the Cost (current US$) in Minerals and Cost (current US$) in Energy?
Offer a very short reply. -1.38e+1. In the year 1981, what is the difference between the Cost (current US$) in Minerals and Cost (current US$) in Forest?
Provide a succinct answer. -7.44e+08. In the year 1981, what is the difference between the Cost (current US$) of Energy and Cost (current US$) of Forest?
Offer a terse response. 1.31e+1. In the year 1982, what is the difference between the Cost (current US$) in CO2 damage and Cost (current US$) in Minerals?
Your answer should be very brief. 2.41e+08. In the year 1982, what is the difference between the Cost (current US$) of CO2 damage and Cost (current US$) of Energy?
Keep it short and to the point. -9.50e+09. In the year 1982, what is the difference between the Cost (current US$) in CO2 damage and Cost (current US$) in Forest?
Give a very brief answer. -5.24e+08. In the year 1982, what is the difference between the Cost (current US$) in Minerals and Cost (current US$) in Energy?
Ensure brevity in your answer.  -9.74e+09. In the year 1982, what is the difference between the Cost (current US$) in Minerals and Cost (current US$) in Forest?
Make the answer very short. -7.65e+08. In the year 1982, what is the difference between the Cost (current US$) of Energy and Cost (current US$) of Forest?
Give a very brief answer. 8.97e+09. In the year 1983, what is the difference between the Cost (current US$) in CO2 damage and Cost (current US$) in Minerals?
Provide a short and direct response. 2.53e+08. In the year 1983, what is the difference between the Cost (current US$) of CO2 damage and Cost (current US$) of Energy?
Provide a succinct answer. -8.53e+09. In the year 1983, what is the difference between the Cost (current US$) in CO2 damage and Cost (current US$) in Forest?
Provide a succinct answer. -5.55e+08. In the year 1983, what is the difference between the Cost (current US$) in Minerals and Cost (current US$) in Energy?
Your response must be concise. -8.78e+09. In the year 1983, what is the difference between the Cost (current US$) of Minerals and Cost (current US$) of Forest?
Your answer should be very brief. -8.08e+08. In the year 1983, what is the difference between the Cost (current US$) of Energy and Cost (current US$) of Forest?
Your response must be concise. 7.97e+09. In the year 1984, what is the difference between the Cost (current US$) of CO2 damage and Cost (current US$) of Minerals?
Provide a succinct answer. 2.95e+08. In the year 1984, what is the difference between the Cost (current US$) of CO2 damage and Cost (current US$) of Energy?
Keep it short and to the point. -9.75e+09. In the year 1984, what is the difference between the Cost (current US$) of CO2 damage and Cost (current US$) of Forest?
Make the answer very short. -2.59e+08. In the year 1984, what is the difference between the Cost (current US$) in Minerals and Cost (current US$) in Energy?
Your answer should be compact. -1.00e+1. In the year 1984, what is the difference between the Cost (current US$) in Minerals and Cost (current US$) in Forest?
Your response must be concise. -5.54e+08. In the year 1984, what is the difference between the Cost (current US$) in Energy and Cost (current US$) in Forest?
Your answer should be very brief. 9.50e+09. In the year 1985, what is the difference between the Cost (current US$) in CO2 damage and Cost (current US$) in Minerals?
Your answer should be very brief. 3.56e+08. In the year 1985, what is the difference between the Cost (current US$) of CO2 damage and Cost (current US$) of Energy?
Keep it short and to the point. -7.74e+09. In the year 1985, what is the difference between the Cost (current US$) in CO2 damage and Cost (current US$) in Forest?
Give a very brief answer. -7.65e+07. In the year 1985, what is the difference between the Cost (current US$) in Minerals and Cost (current US$) in Energy?
Keep it short and to the point. -8.10e+09. In the year 1985, what is the difference between the Cost (current US$) of Minerals and Cost (current US$) of Forest?
Provide a succinct answer. -4.32e+08. In the year 1985, what is the difference between the Cost (current US$) of Energy and Cost (current US$) of Forest?
Offer a very short reply. 7.67e+09. What is the ratio of the Cost (current US$) in CO2 damage in 1979 to that in 1980?
Offer a very short reply. 0.91. What is the ratio of the Cost (current US$) in Minerals in 1979 to that in 1980?
Your answer should be very brief. 0.86. What is the ratio of the Cost (current US$) in Energy in 1979 to that in 1980?
Your answer should be very brief. 0.87. What is the ratio of the Cost (current US$) in Forest in 1979 to that in 1980?
Provide a short and direct response. 0.86. What is the ratio of the Cost (current US$) in CO2 damage in 1979 to that in 1981?
Keep it short and to the point. 0.78. What is the ratio of the Cost (current US$) of Minerals in 1979 to that in 1981?
Make the answer very short. 1.22. What is the ratio of the Cost (current US$) of Energy in 1979 to that in 1981?
Make the answer very short. 0.89. What is the ratio of the Cost (current US$) of Forest in 1979 to that in 1981?
Make the answer very short. 1.19. What is the ratio of the Cost (current US$) in CO2 damage in 1979 to that in 1982?
Offer a terse response. 0.69. What is the ratio of the Cost (current US$) in Minerals in 1979 to that in 1982?
Your response must be concise. 1.8. What is the ratio of the Cost (current US$) of Energy in 1979 to that in 1982?
Ensure brevity in your answer.  1.27. What is the ratio of the Cost (current US$) of Forest in 1979 to that in 1982?
Your answer should be compact. 1.24. What is the ratio of the Cost (current US$) of CO2 damage in 1979 to that in 1983?
Your response must be concise. 0.66. What is the ratio of the Cost (current US$) in Minerals in 1979 to that in 1983?
Give a very brief answer. 1.72. What is the ratio of the Cost (current US$) in Energy in 1979 to that in 1983?
Your response must be concise. 1.4. What is the ratio of the Cost (current US$) in Forest in 1979 to that in 1983?
Ensure brevity in your answer.  1.18. What is the ratio of the Cost (current US$) in CO2 damage in 1979 to that in 1984?
Keep it short and to the point. 0.59. What is the ratio of the Cost (current US$) in Minerals in 1979 to that in 1984?
Make the answer very short. 1.67. What is the ratio of the Cost (current US$) of Energy in 1979 to that in 1984?
Offer a very short reply. 1.23. What is the ratio of the Cost (current US$) in Forest in 1979 to that in 1984?
Provide a succinct answer. 1.61. What is the ratio of the Cost (current US$) of CO2 damage in 1979 to that in 1985?
Provide a succinct answer. 0.52. What is the ratio of the Cost (current US$) of Minerals in 1979 to that in 1985?
Keep it short and to the point. 1.75. What is the ratio of the Cost (current US$) in Energy in 1979 to that in 1985?
Provide a succinct answer. 1.52. What is the ratio of the Cost (current US$) in Forest in 1979 to that in 1985?
Give a very brief answer. 1.97. What is the ratio of the Cost (current US$) of CO2 damage in 1980 to that in 1981?
Give a very brief answer. 0.86. What is the ratio of the Cost (current US$) in Minerals in 1980 to that in 1981?
Make the answer very short. 1.42. What is the ratio of the Cost (current US$) in Energy in 1980 to that in 1981?
Make the answer very short. 1.02. What is the ratio of the Cost (current US$) in Forest in 1980 to that in 1981?
Your answer should be very brief. 1.38. What is the ratio of the Cost (current US$) in CO2 damage in 1980 to that in 1982?
Your answer should be very brief. 0.76. What is the ratio of the Cost (current US$) in Minerals in 1980 to that in 1982?
Your response must be concise. 2.1. What is the ratio of the Cost (current US$) in Energy in 1980 to that in 1982?
Provide a short and direct response. 1.45. What is the ratio of the Cost (current US$) of Forest in 1980 to that in 1982?
Provide a short and direct response. 1.44. What is the ratio of the Cost (current US$) in CO2 damage in 1980 to that in 1983?
Offer a very short reply. 0.72. What is the ratio of the Cost (current US$) of Minerals in 1980 to that in 1983?
Provide a short and direct response. 2.01. What is the ratio of the Cost (current US$) in Energy in 1980 to that in 1983?
Provide a succinct answer. 1.61. What is the ratio of the Cost (current US$) of Forest in 1980 to that in 1983?
Provide a short and direct response. 1.37. What is the ratio of the Cost (current US$) of CO2 damage in 1980 to that in 1984?
Provide a short and direct response. 0.65. What is the ratio of the Cost (current US$) of Minerals in 1980 to that in 1984?
Keep it short and to the point. 1.95. What is the ratio of the Cost (current US$) of Energy in 1980 to that in 1984?
Your answer should be very brief. 1.41. What is the ratio of the Cost (current US$) of Forest in 1980 to that in 1984?
Ensure brevity in your answer.  1.86. What is the ratio of the Cost (current US$) of CO2 damage in 1980 to that in 1985?
Provide a succinct answer. 0.57. What is the ratio of the Cost (current US$) in Minerals in 1980 to that in 1985?
Ensure brevity in your answer.  2.04. What is the ratio of the Cost (current US$) of Energy in 1980 to that in 1985?
Provide a short and direct response. 1.74. What is the ratio of the Cost (current US$) in Forest in 1980 to that in 1985?
Ensure brevity in your answer.  2.29. What is the ratio of the Cost (current US$) of CO2 damage in 1981 to that in 1982?
Make the answer very short. 0.88. What is the ratio of the Cost (current US$) of Minerals in 1981 to that in 1982?
Your answer should be compact. 1.48. What is the ratio of the Cost (current US$) in Energy in 1981 to that in 1982?
Provide a short and direct response. 1.42. What is the ratio of the Cost (current US$) of Forest in 1981 to that in 1982?
Provide a short and direct response. 1.04. What is the ratio of the Cost (current US$) in CO2 damage in 1981 to that in 1983?
Your answer should be very brief. 0.84. What is the ratio of the Cost (current US$) in Minerals in 1981 to that in 1983?
Provide a short and direct response. 1.41. What is the ratio of the Cost (current US$) of Energy in 1981 to that in 1983?
Give a very brief answer. 1.57. What is the ratio of the Cost (current US$) in Forest in 1981 to that in 1983?
Provide a succinct answer. 0.99. What is the ratio of the Cost (current US$) in CO2 damage in 1981 to that in 1984?
Ensure brevity in your answer.  0.75. What is the ratio of the Cost (current US$) of Minerals in 1981 to that in 1984?
Offer a very short reply. 1.37. What is the ratio of the Cost (current US$) in Energy in 1981 to that in 1984?
Your answer should be compact. 1.37. What is the ratio of the Cost (current US$) in Forest in 1981 to that in 1984?
Ensure brevity in your answer.  1.35. What is the ratio of the Cost (current US$) of CO2 damage in 1981 to that in 1985?
Provide a succinct answer. 0.67. What is the ratio of the Cost (current US$) in Minerals in 1981 to that in 1985?
Ensure brevity in your answer.  1.43. What is the ratio of the Cost (current US$) of Energy in 1981 to that in 1985?
Ensure brevity in your answer.  1.7. What is the ratio of the Cost (current US$) of Forest in 1981 to that in 1985?
Offer a very short reply. 1.66. What is the ratio of the Cost (current US$) of CO2 damage in 1982 to that in 1983?
Your answer should be very brief. 0.95. What is the ratio of the Cost (current US$) of Minerals in 1982 to that in 1983?
Your response must be concise. 0.96. What is the ratio of the Cost (current US$) in Energy in 1982 to that in 1983?
Make the answer very short. 1.11. What is the ratio of the Cost (current US$) of Forest in 1982 to that in 1983?
Keep it short and to the point. 0.95. What is the ratio of the Cost (current US$) of CO2 damage in 1982 to that in 1984?
Provide a short and direct response. 0.85. What is the ratio of the Cost (current US$) of Minerals in 1982 to that in 1984?
Keep it short and to the point. 0.93. What is the ratio of the Cost (current US$) of Energy in 1982 to that in 1984?
Make the answer very short. 0.97. What is the ratio of the Cost (current US$) of Forest in 1982 to that in 1984?
Offer a terse response. 1.29. What is the ratio of the Cost (current US$) in CO2 damage in 1982 to that in 1985?
Make the answer very short. 0.76. What is the ratio of the Cost (current US$) of Minerals in 1982 to that in 1985?
Provide a short and direct response. 0.97. What is the ratio of the Cost (current US$) in Energy in 1982 to that in 1985?
Provide a short and direct response. 1.2. What is the ratio of the Cost (current US$) in Forest in 1982 to that in 1985?
Offer a very short reply. 1.59. What is the ratio of the Cost (current US$) in CO2 damage in 1983 to that in 1984?
Your answer should be very brief. 0.89. What is the ratio of the Cost (current US$) of Minerals in 1983 to that in 1984?
Your response must be concise. 0.97. What is the ratio of the Cost (current US$) of Energy in 1983 to that in 1984?
Provide a short and direct response. 0.87. What is the ratio of the Cost (current US$) of Forest in 1983 to that in 1984?
Provide a short and direct response. 1.36. What is the ratio of the Cost (current US$) of CO2 damage in 1983 to that in 1985?
Provide a short and direct response. 0.79. What is the ratio of the Cost (current US$) in Minerals in 1983 to that in 1985?
Offer a very short reply. 1.02. What is the ratio of the Cost (current US$) in Energy in 1983 to that in 1985?
Offer a terse response. 1.08. What is the ratio of the Cost (current US$) in Forest in 1983 to that in 1985?
Your answer should be compact. 1.67. What is the ratio of the Cost (current US$) in CO2 damage in 1984 to that in 1985?
Your answer should be very brief. 0.89. What is the ratio of the Cost (current US$) of Minerals in 1984 to that in 1985?
Offer a very short reply. 1.05. What is the ratio of the Cost (current US$) of Energy in 1984 to that in 1985?
Offer a terse response. 1.24. What is the ratio of the Cost (current US$) in Forest in 1984 to that in 1985?
Provide a short and direct response. 1.23. What is the difference between the highest and the second highest Cost (current US$) in CO2 damage?
Your answer should be compact. 5.51e+07. What is the difference between the highest and the second highest Cost (current US$) in Minerals?
Ensure brevity in your answer.  3.74e+07. What is the difference between the highest and the second highest Cost (current US$) of Energy?
Ensure brevity in your answer.  3.34e+08. What is the difference between the highest and the second highest Cost (current US$) of Forest?
Offer a terse response. 1.76e+08. What is the difference between the highest and the lowest Cost (current US$) in CO2 damage?
Provide a succinct answer. 2.33e+08. What is the difference between the highest and the lowest Cost (current US$) in Minerals?
Your answer should be very brief. 1.37e+08. What is the difference between the highest and the lowest Cost (current US$) of Energy?
Keep it short and to the point. 6.09e+09. What is the difference between the highest and the lowest Cost (current US$) of Forest?
Offer a terse response. 7.22e+08. 